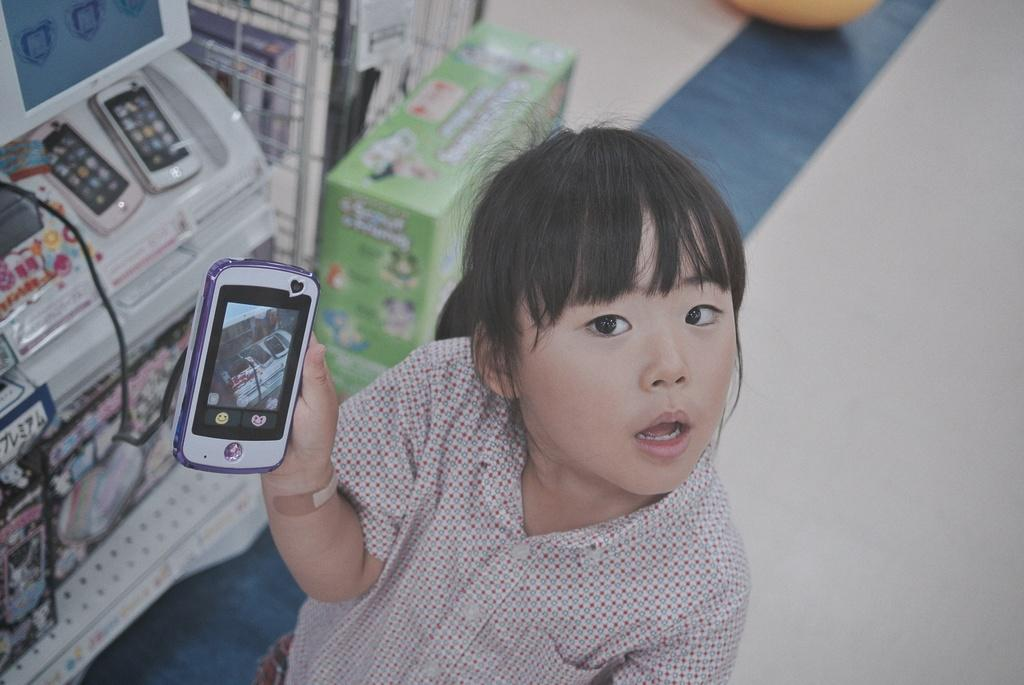Where was the image taken? The image was taken in a store. What is the girl in the foreground of the picture doing? The girl is holding a mobile in the foreground of the picture. What can be seen on the left side of the picture? There are toys on the left side of the picture, in racks and shelves. What is visible on the right side of the picture? The right side of the picture shows the floor. What type of hen can be seen in the image? There is no hen present in the image. Is the girl's uncle in the image? There is no information about the girl's uncle in the image. Can you see any popcorn in the image? There is no popcorn visible in the image. 